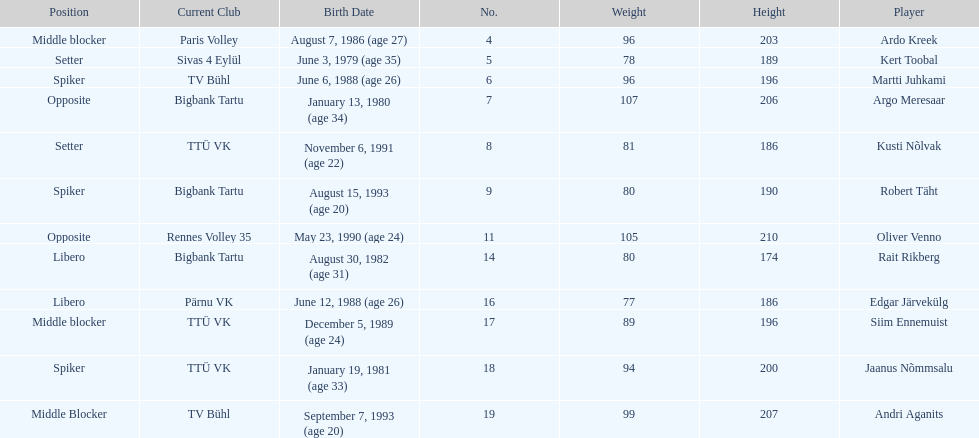Which player is taller than andri agantis? Oliver Venno. 